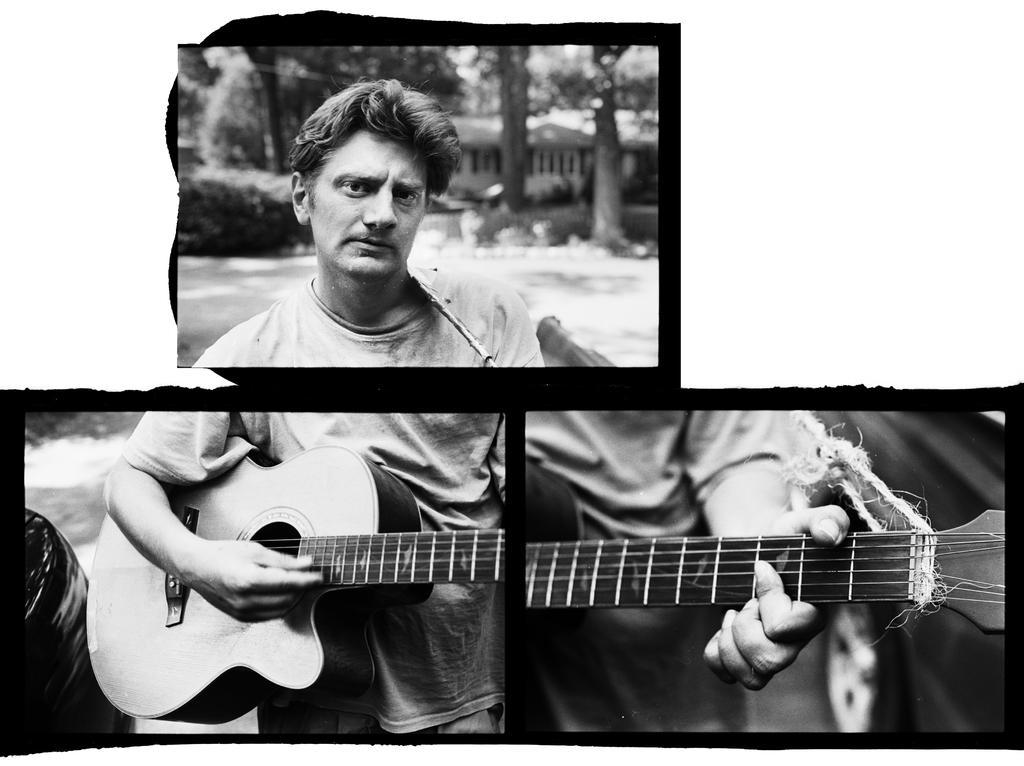How would you summarize this image in a sentence or two? This is an edited image, this is a black and white image. There is a person in this who is holding guitar. He is playing that guitar, there are trees on the top and in the bottom right corner there is a car. He is wearing a t-shirt. 